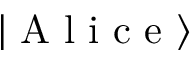<formula> <loc_0><loc_0><loc_500><loc_500>\left | A l i c e \right \rangle</formula> 